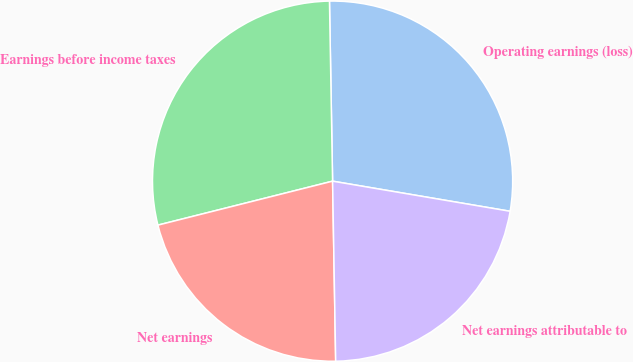Convert chart. <chart><loc_0><loc_0><loc_500><loc_500><pie_chart><fcel>Operating earnings (loss)<fcel>Earnings before income taxes<fcel>Net earnings<fcel>Net earnings attributable to<nl><fcel>27.95%<fcel>28.65%<fcel>21.35%<fcel>22.05%<nl></chart> 